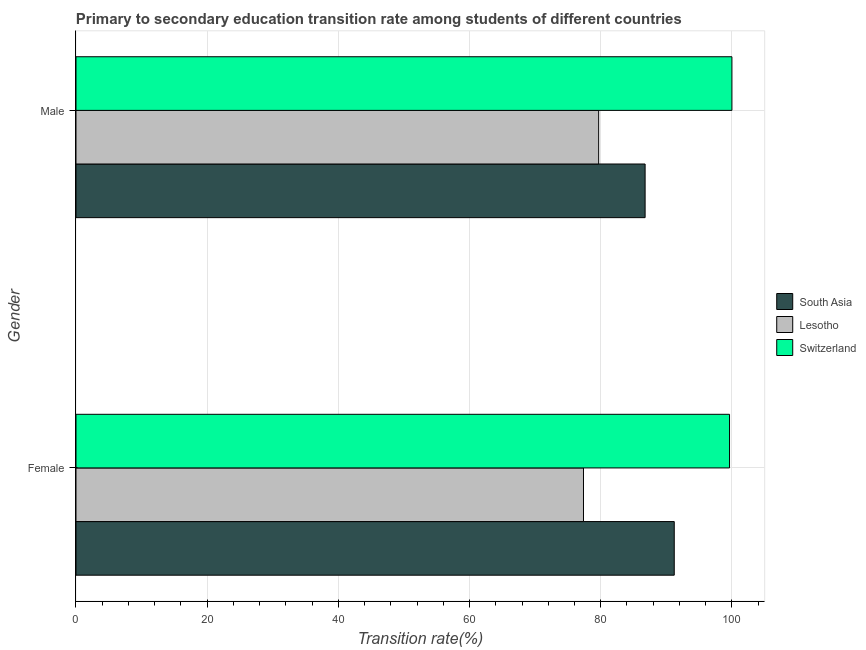How many groups of bars are there?
Provide a succinct answer. 2. Are the number of bars per tick equal to the number of legend labels?
Provide a short and direct response. Yes. What is the label of the 2nd group of bars from the top?
Offer a very short reply. Female. Across all countries, what is the maximum transition rate among female students?
Your response must be concise. 99.64. Across all countries, what is the minimum transition rate among female students?
Provide a succinct answer. 77.37. In which country was the transition rate among female students maximum?
Your answer should be very brief. Switzerland. In which country was the transition rate among female students minimum?
Provide a short and direct response. Lesotho. What is the total transition rate among male students in the graph?
Your response must be concise. 266.45. What is the difference between the transition rate among male students in Lesotho and that in South Asia?
Give a very brief answer. -7.08. What is the difference between the transition rate among female students in Lesotho and the transition rate among male students in Switzerland?
Keep it short and to the point. -22.63. What is the average transition rate among female students per country?
Your response must be concise. 89.41. What is the difference between the transition rate among female students and transition rate among male students in Lesotho?
Provide a succinct answer. -2.32. What is the ratio of the transition rate among male students in Lesotho to that in South Asia?
Keep it short and to the point. 0.92. In how many countries, is the transition rate among female students greater than the average transition rate among female students taken over all countries?
Your answer should be compact. 2. What does the 1st bar from the top in Male represents?
Your response must be concise. Switzerland. What does the 2nd bar from the bottom in Male represents?
Your answer should be very brief. Lesotho. How many bars are there?
Your answer should be very brief. 6. Are all the bars in the graph horizontal?
Offer a terse response. Yes. How many countries are there in the graph?
Your response must be concise. 3. What is the difference between two consecutive major ticks on the X-axis?
Offer a terse response. 20. Does the graph contain any zero values?
Your answer should be compact. No. Where does the legend appear in the graph?
Give a very brief answer. Center right. How many legend labels are there?
Your answer should be compact. 3. What is the title of the graph?
Offer a terse response. Primary to secondary education transition rate among students of different countries. What is the label or title of the X-axis?
Your answer should be very brief. Transition rate(%). What is the label or title of the Y-axis?
Make the answer very short. Gender. What is the Transition rate(%) of South Asia in Female?
Your answer should be compact. 91.21. What is the Transition rate(%) of Lesotho in Female?
Provide a succinct answer. 77.37. What is the Transition rate(%) of Switzerland in Female?
Give a very brief answer. 99.64. What is the Transition rate(%) in South Asia in Male?
Your response must be concise. 86.77. What is the Transition rate(%) in Lesotho in Male?
Offer a terse response. 79.69. Across all Gender, what is the maximum Transition rate(%) in South Asia?
Keep it short and to the point. 91.21. Across all Gender, what is the maximum Transition rate(%) in Lesotho?
Provide a succinct answer. 79.69. Across all Gender, what is the maximum Transition rate(%) in Switzerland?
Offer a very short reply. 100. Across all Gender, what is the minimum Transition rate(%) in South Asia?
Give a very brief answer. 86.77. Across all Gender, what is the minimum Transition rate(%) of Lesotho?
Your answer should be compact. 77.37. Across all Gender, what is the minimum Transition rate(%) in Switzerland?
Provide a succinct answer. 99.64. What is the total Transition rate(%) in South Asia in the graph?
Make the answer very short. 177.98. What is the total Transition rate(%) of Lesotho in the graph?
Make the answer very short. 157.06. What is the total Transition rate(%) in Switzerland in the graph?
Your response must be concise. 199.64. What is the difference between the Transition rate(%) in South Asia in Female and that in Male?
Offer a terse response. 4.44. What is the difference between the Transition rate(%) in Lesotho in Female and that in Male?
Offer a very short reply. -2.32. What is the difference between the Transition rate(%) in Switzerland in Female and that in Male?
Provide a short and direct response. -0.36. What is the difference between the Transition rate(%) of South Asia in Female and the Transition rate(%) of Lesotho in Male?
Offer a terse response. 11.52. What is the difference between the Transition rate(%) in South Asia in Female and the Transition rate(%) in Switzerland in Male?
Keep it short and to the point. -8.79. What is the difference between the Transition rate(%) in Lesotho in Female and the Transition rate(%) in Switzerland in Male?
Make the answer very short. -22.63. What is the average Transition rate(%) in South Asia per Gender?
Offer a terse response. 88.99. What is the average Transition rate(%) of Lesotho per Gender?
Make the answer very short. 78.53. What is the average Transition rate(%) in Switzerland per Gender?
Provide a succinct answer. 99.82. What is the difference between the Transition rate(%) in South Asia and Transition rate(%) in Lesotho in Female?
Offer a terse response. 13.84. What is the difference between the Transition rate(%) of South Asia and Transition rate(%) of Switzerland in Female?
Your answer should be very brief. -8.43. What is the difference between the Transition rate(%) of Lesotho and Transition rate(%) of Switzerland in Female?
Offer a terse response. -22.27. What is the difference between the Transition rate(%) of South Asia and Transition rate(%) of Lesotho in Male?
Ensure brevity in your answer.  7.08. What is the difference between the Transition rate(%) in South Asia and Transition rate(%) in Switzerland in Male?
Give a very brief answer. -13.23. What is the difference between the Transition rate(%) in Lesotho and Transition rate(%) in Switzerland in Male?
Offer a very short reply. -20.31. What is the ratio of the Transition rate(%) of South Asia in Female to that in Male?
Offer a very short reply. 1.05. What is the ratio of the Transition rate(%) of Lesotho in Female to that in Male?
Your response must be concise. 0.97. What is the difference between the highest and the second highest Transition rate(%) in South Asia?
Your answer should be very brief. 4.44. What is the difference between the highest and the second highest Transition rate(%) of Lesotho?
Keep it short and to the point. 2.32. What is the difference between the highest and the second highest Transition rate(%) in Switzerland?
Offer a terse response. 0.36. What is the difference between the highest and the lowest Transition rate(%) of South Asia?
Keep it short and to the point. 4.44. What is the difference between the highest and the lowest Transition rate(%) in Lesotho?
Your response must be concise. 2.32. What is the difference between the highest and the lowest Transition rate(%) in Switzerland?
Provide a short and direct response. 0.36. 